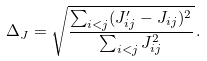Convert formula to latex. <formula><loc_0><loc_0><loc_500><loc_500>\Delta _ { J } = \sqrt { \frac { \sum _ { i < j } ( J ^ { \prime } _ { i j } - J _ { i j } ) ^ { 2 } } { \sum _ { i < j } J _ { i j } ^ { 2 } } } \, .</formula> 